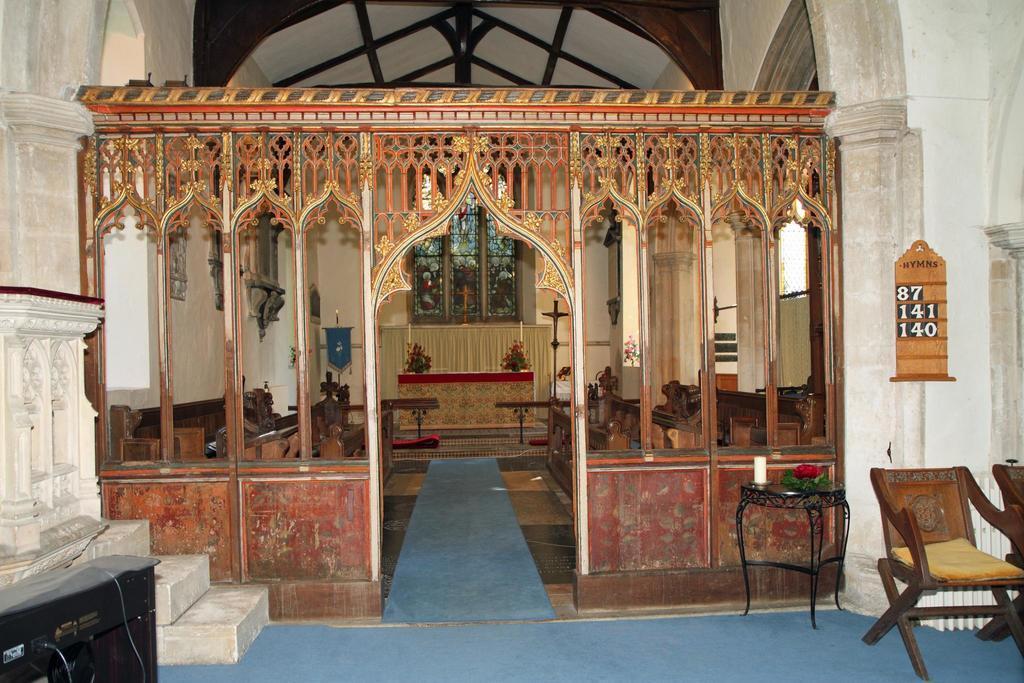In one or two sentences, can you explain what this image depicts? In the picture we can see a inside view of the church with a design wall and in the background we can see a cross sign and table under it with a curtain and besides we can see flower plants and outside of the designed wall we can see a chair. 